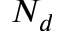<formula> <loc_0><loc_0><loc_500><loc_500>N _ { d }</formula> 